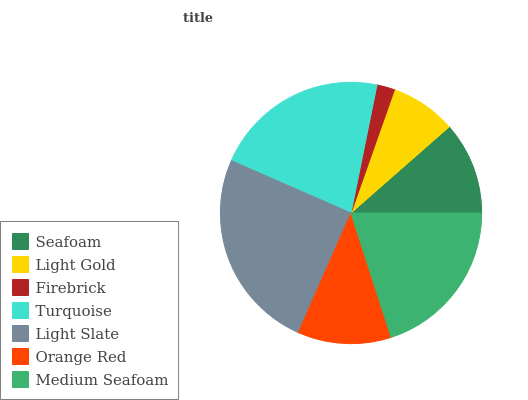Is Firebrick the minimum?
Answer yes or no. Yes. Is Light Slate the maximum?
Answer yes or no. Yes. Is Light Gold the minimum?
Answer yes or no. No. Is Light Gold the maximum?
Answer yes or no. No. Is Seafoam greater than Light Gold?
Answer yes or no. Yes. Is Light Gold less than Seafoam?
Answer yes or no. Yes. Is Light Gold greater than Seafoam?
Answer yes or no. No. Is Seafoam less than Light Gold?
Answer yes or no. No. Is Orange Red the high median?
Answer yes or no. Yes. Is Orange Red the low median?
Answer yes or no. Yes. Is Seafoam the high median?
Answer yes or no. No. Is Seafoam the low median?
Answer yes or no. No. 